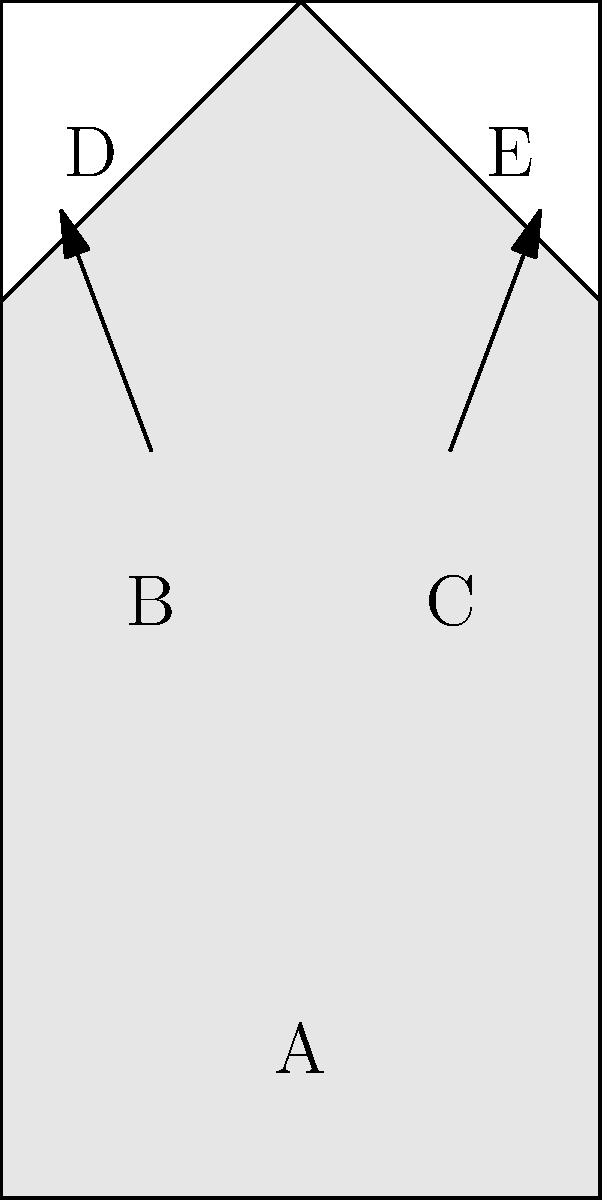As a former striker who understands the importance of jersey design, imagine you're helping to create a new national team kit. The image shows an unfolded pattern for a soccer jersey. Which two parts need to be folded upwards to form the sleeves of the final shirt? To solve this problem, we need to mentally visualize the folding process of the jersey pattern:

1. The main body of the jersey is represented by the central rectangle (parts A, B, and C).
2. The two triangular pieces at the top (D and E) are clearly separate from the main body.
3. These triangular pieces (D and E) are positioned where the sleeves would typically be on a shirt.
4. The arrows in the diagram indicate an upward folding motion for these triangular pieces.
5. When folded upwards, these triangular pieces would form tube-like structures on either side of the main body, which is consistent with the shape of sleeves.
6. Parts B and C are integral to the main body and don't need to be folded to form the final shirt shape.

Therefore, the two parts that need to be folded upwards to form the sleeves are the triangular pieces labeled D and E.
Answer: D and E 